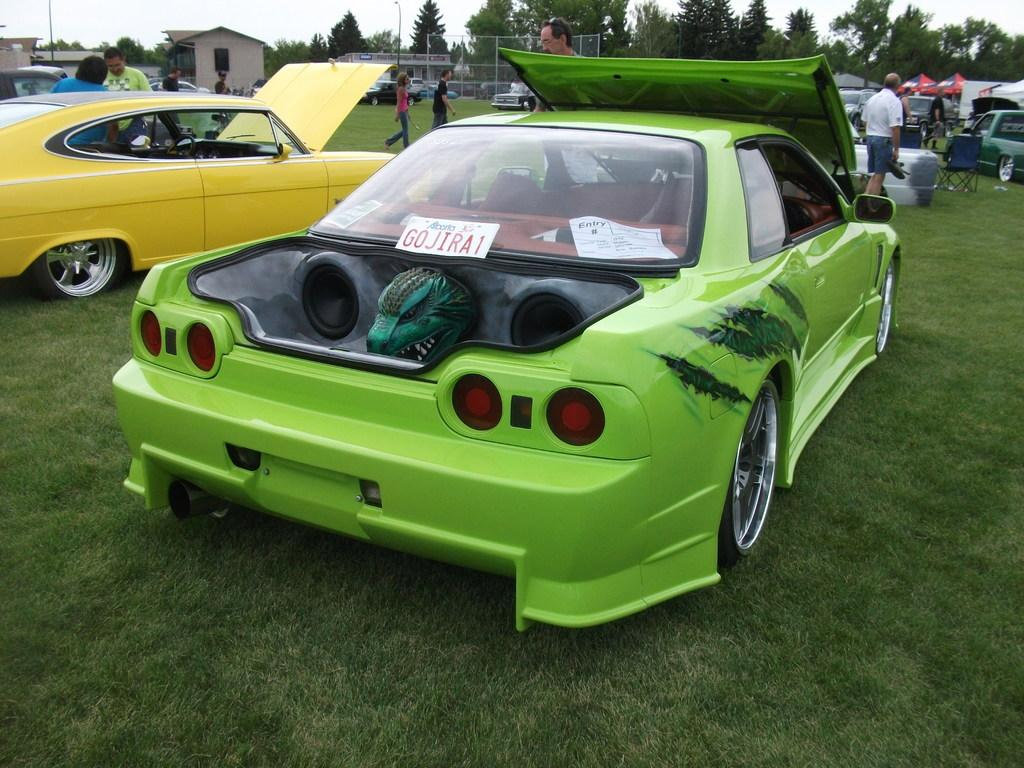<image>
Write a terse but informative summary of the picture. a green sports car with an Alberta license plate GOJIRA1 